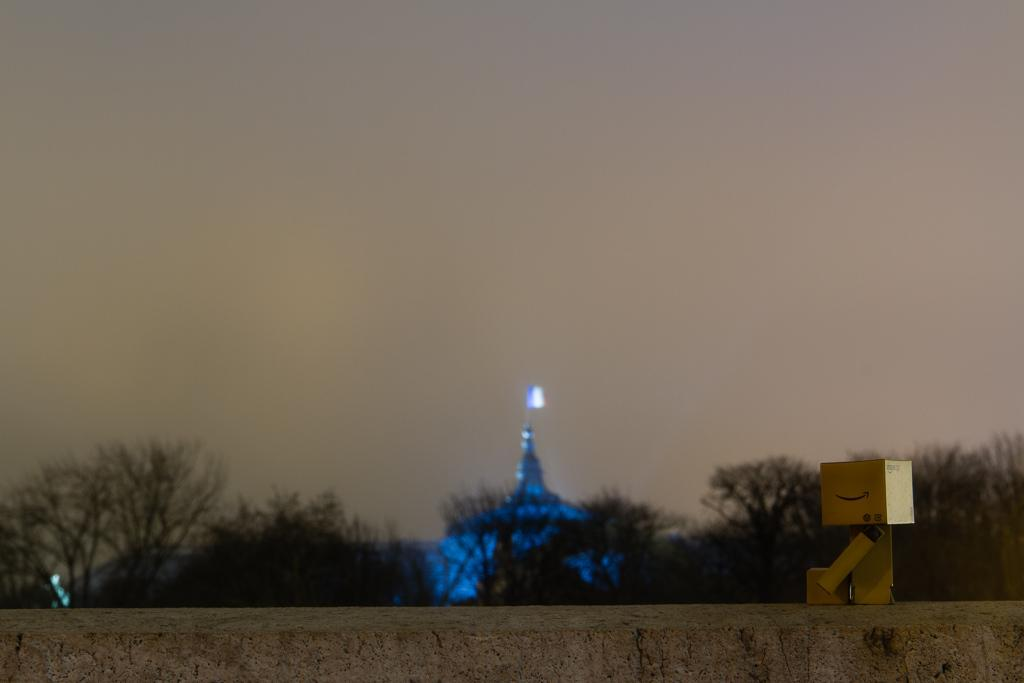What material is the main object in the image made of? The main object in the image is made up of wood. What can be seen in the background of the image? There are trees and the sky visible in the background of the image. How many snails can be seen crawling on the wooden object in the image? There are no snails visible on the wooden object in the image. What type of end is attached to the wooden object in the image? The wooden object in the image does not have any ends, as it is not a tool or device with a specific function. 